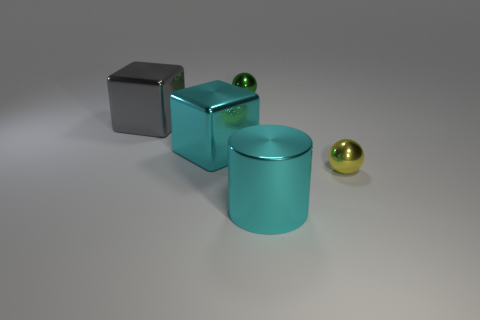There is a gray block; is its size the same as the metallic sphere in front of the gray metallic object?
Ensure brevity in your answer.  No. How many objects are cyan cubes or yellow spheres?
Ensure brevity in your answer.  2. How many metallic cubes are the same color as the metal cylinder?
Make the answer very short. 1. What is the shape of the yellow thing that is the same size as the green metallic ball?
Give a very brief answer. Sphere. Are there any other small objects that have the same shape as the small green thing?
Give a very brief answer. Yes. What number of big things are the same material as the big cyan cylinder?
Give a very brief answer. 2. Does the object that is right of the large cyan cylinder have the same material as the gray block?
Ensure brevity in your answer.  Yes. Is the number of yellow metal balls in front of the green sphere greater than the number of metallic balls behind the cylinder?
Keep it short and to the point. No. What is the material of the other object that is the same size as the green object?
Your answer should be compact. Metal. How many other things are made of the same material as the large gray thing?
Make the answer very short. 4. 